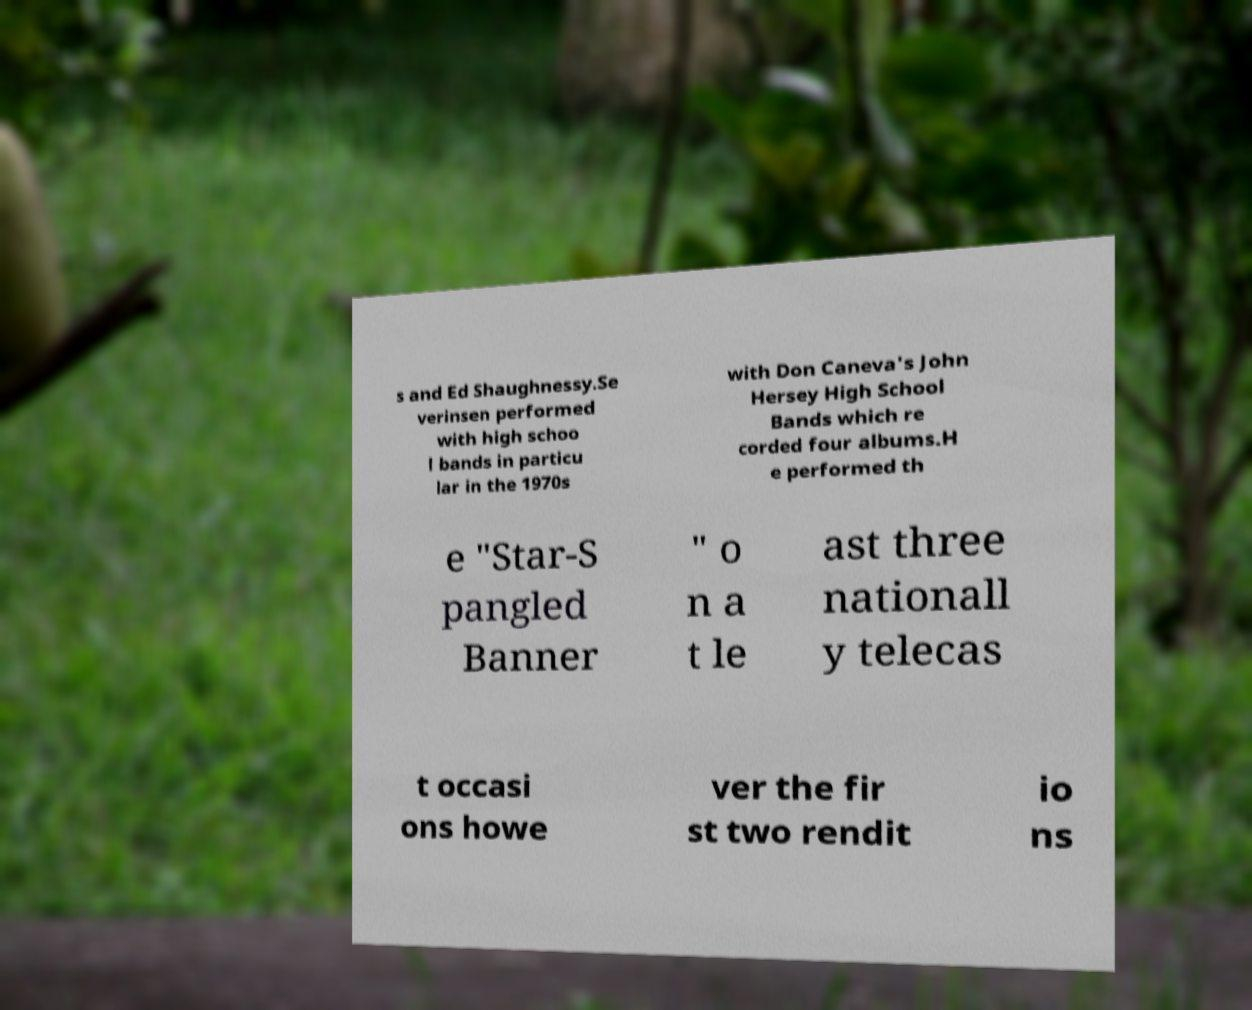Please identify and transcribe the text found in this image. s and Ed Shaughnessy.Se verinsen performed with high schoo l bands in particu lar in the 1970s with Don Caneva's John Hersey High School Bands which re corded four albums.H e performed th e "Star-S pangled Banner " o n a t le ast three nationall y telecas t occasi ons howe ver the fir st two rendit io ns 